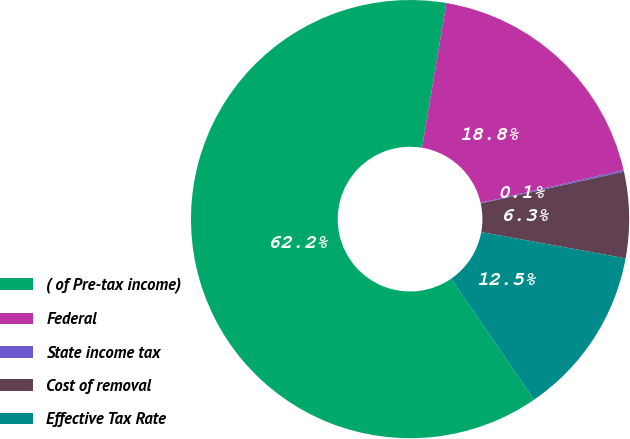Convert chart. <chart><loc_0><loc_0><loc_500><loc_500><pie_chart><fcel>( of Pre-tax income)<fcel>Federal<fcel>State income tax<fcel>Cost of removal<fcel>Effective Tax Rate<nl><fcel>62.24%<fcel>18.76%<fcel>0.12%<fcel>6.34%<fcel>12.55%<nl></chart> 